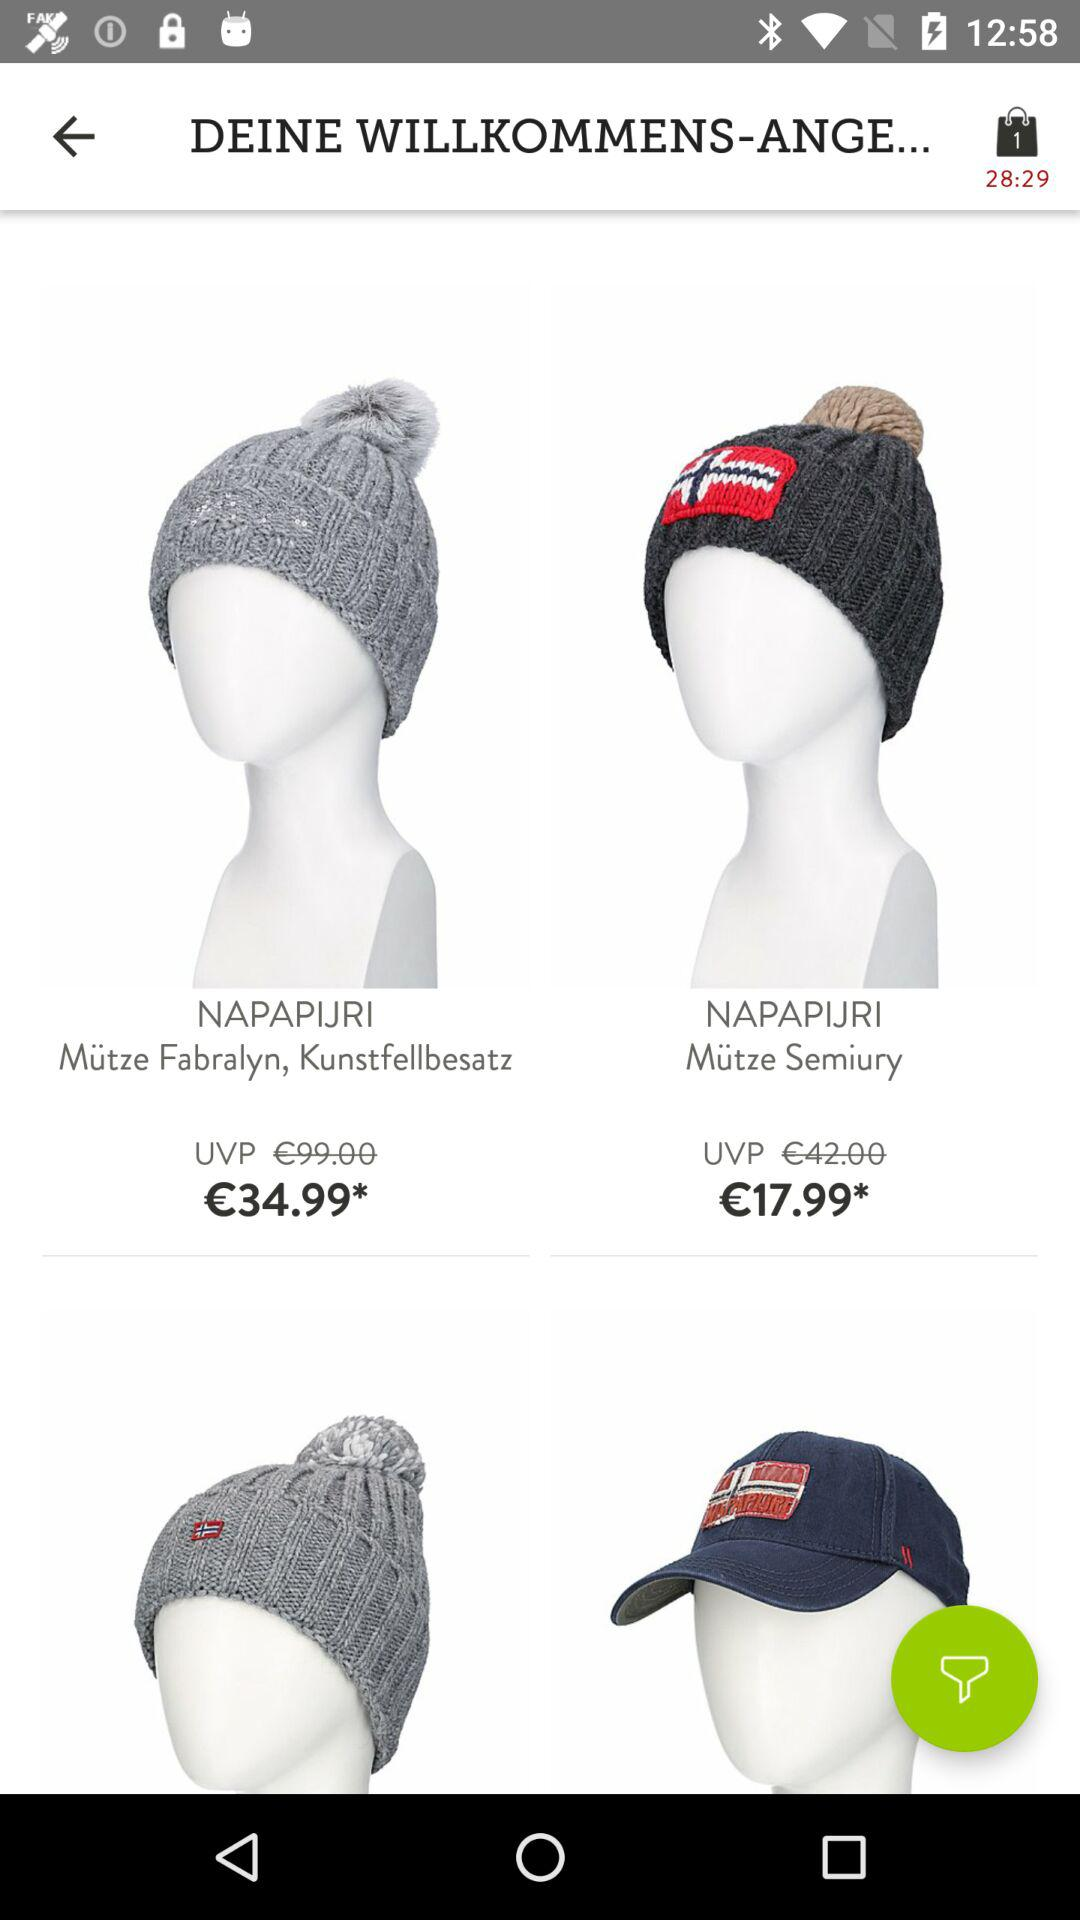What's the price of "NAPAPIJRI Mütze Semiury"? The price of "NAPAPIJRI Mütze Semiury" is €17.99. 